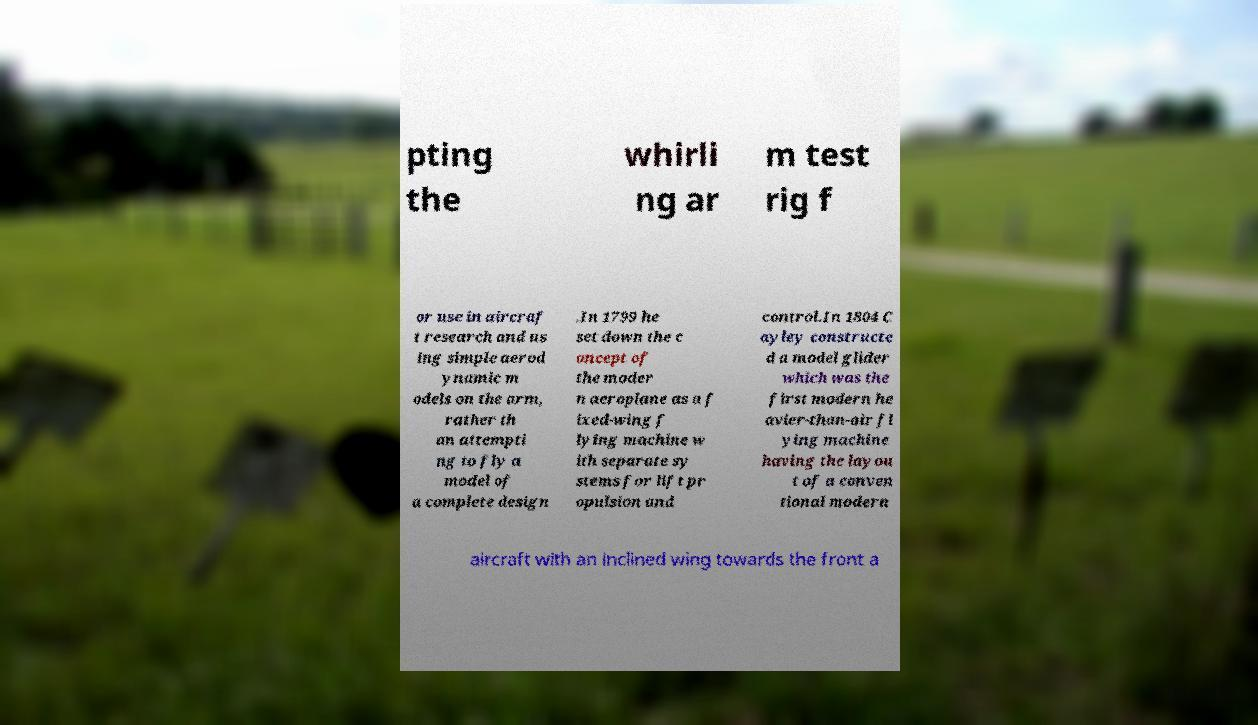Could you assist in decoding the text presented in this image and type it out clearly? pting the whirli ng ar m test rig f or use in aircraf t research and us ing simple aerod ynamic m odels on the arm, rather th an attempti ng to fly a model of a complete design .In 1799 he set down the c oncept of the moder n aeroplane as a f ixed-wing f lying machine w ith separate sy stems for lift pr opulsion and control.In 1804 C ayley constructe d a model glider which was the first modern he avier-than-air fl ying machine having the layou t of a conven tional modern aircraft with an inclined wing towards the front a 